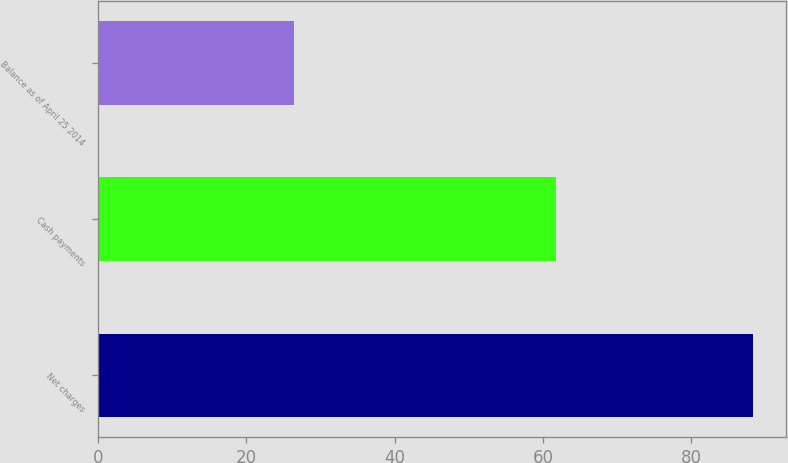Convert chart. <chart><loc_0><loc_0><loc_500><loc_500><bar_chart><fcel>Net charges<fcel>Cash payments<fcel>Balance as of April 25 2014<nl><fcel>88.3<fcel>61.8<fcel>26.5<nl></chart> 